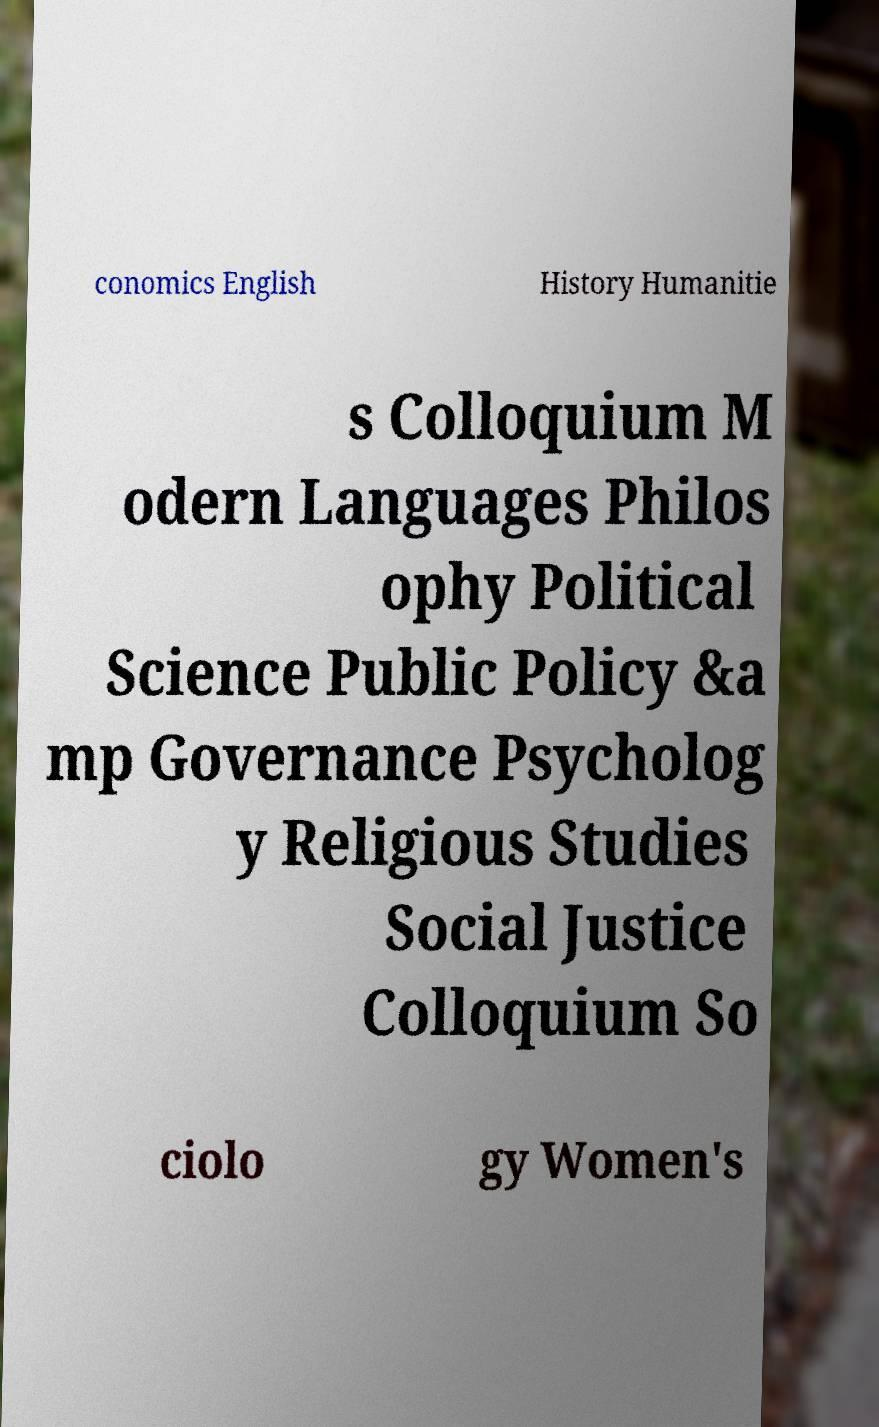I need the written content from this picture converted into text. Can you do that? conomics English History Humanitie s Colloquium M odern Languages Philos ophy Political Science Public Policy &a mp Governance Psycholog y Religious Studies Social Justice Colloquium So ciolo gy Women's 